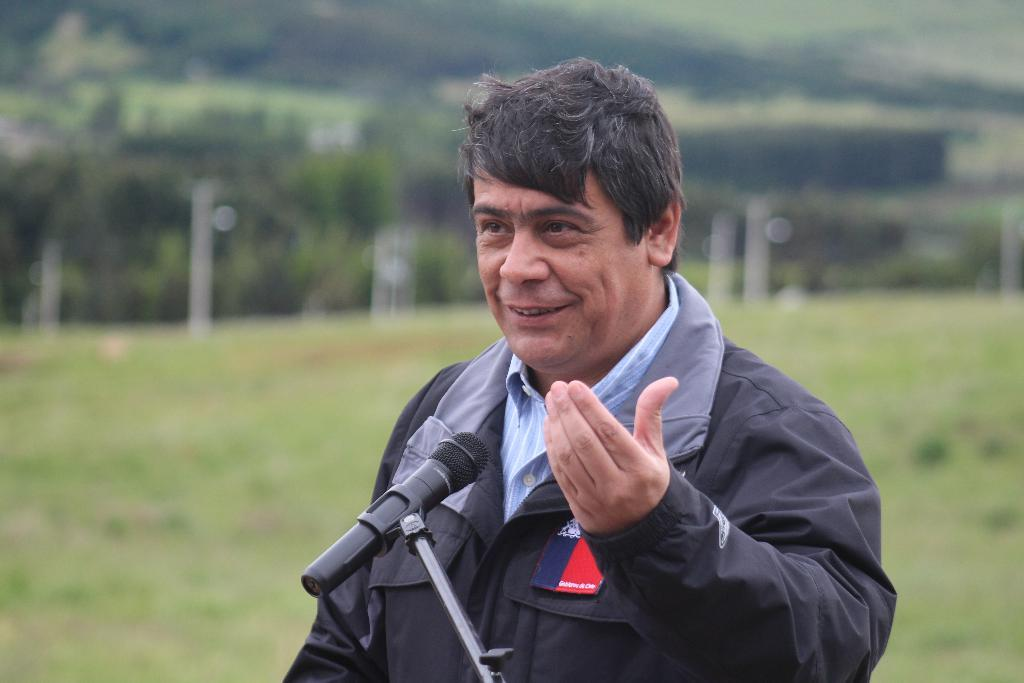Who is present in the image? There is a man in the image. What is the man wearing? The man is wearing a black jacket. What object is in front of the man? There is a microphone in front of the man. What can be seen in the background of the image? There are trees visible behind the man. What type of plough is being used to cultivate the field in the image? There is no plough or field present in the image; it features a man with a microphone and trees in the background. How many bombs are visible in the image? There are no bombs present in the image. 